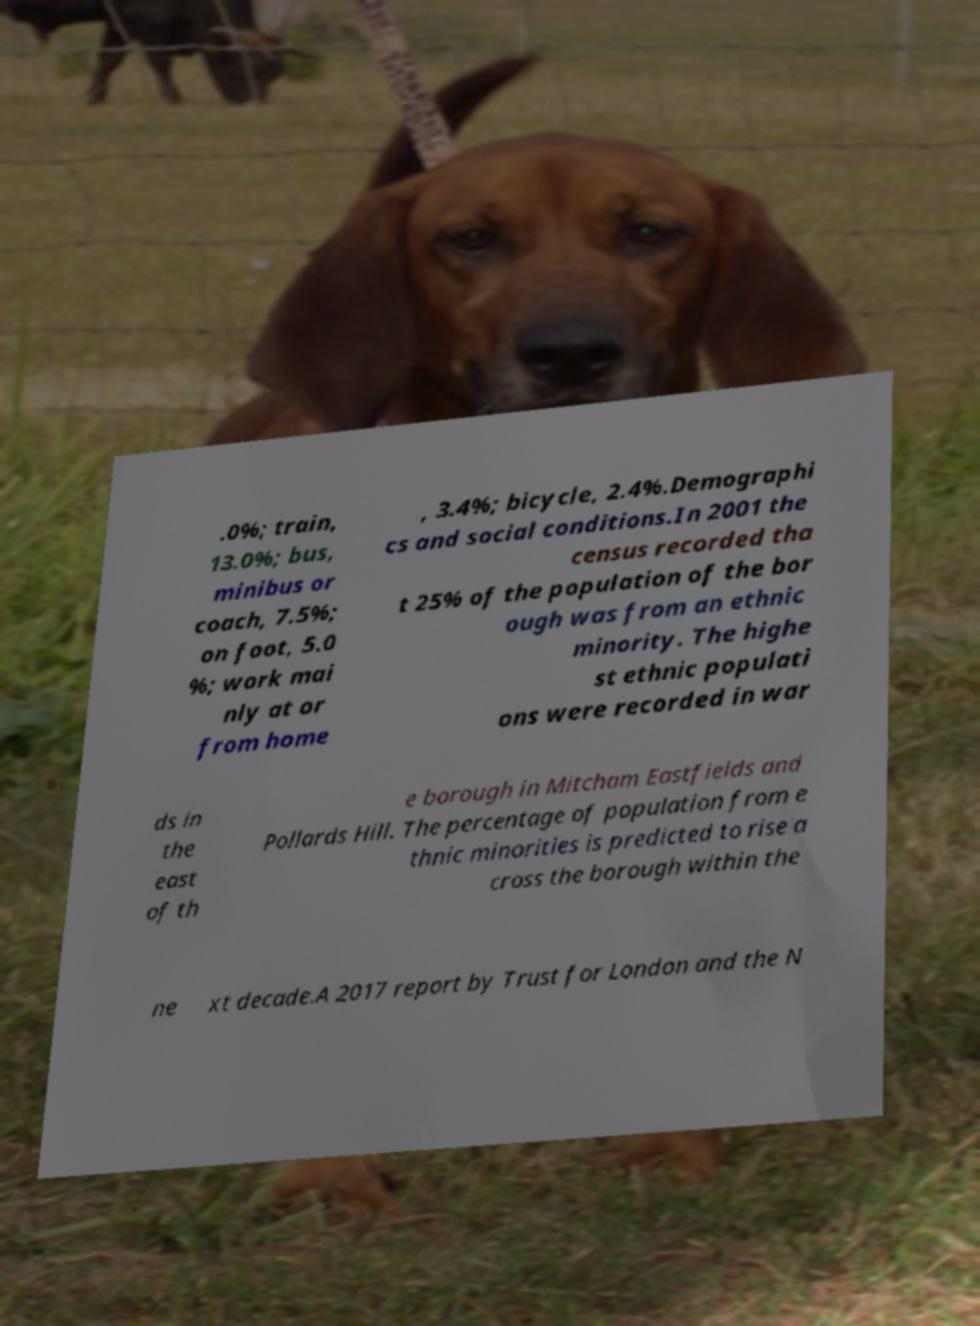Please identify and transcribe the text found in this image. .0%; train, 13.0%; bus, minibus or coach, 7.5%; on foot, 5.0 %; work mai nly at or from home , 3.4%; bicycle, 2.4%.Demographi cs and social conditions.In 2001 the census recorded tha t 25% of the population of the bor ough was from an ethnic minority. The highe st ethnic populati ons were recorded in war ds in the east of th e borough in Mitcham Eastfields and Pollards Hill. The percentage of population from e thnic minorities is predicted to rise a cross the borough within the ne xt decade.A 2017 report by Trust for London and the N 